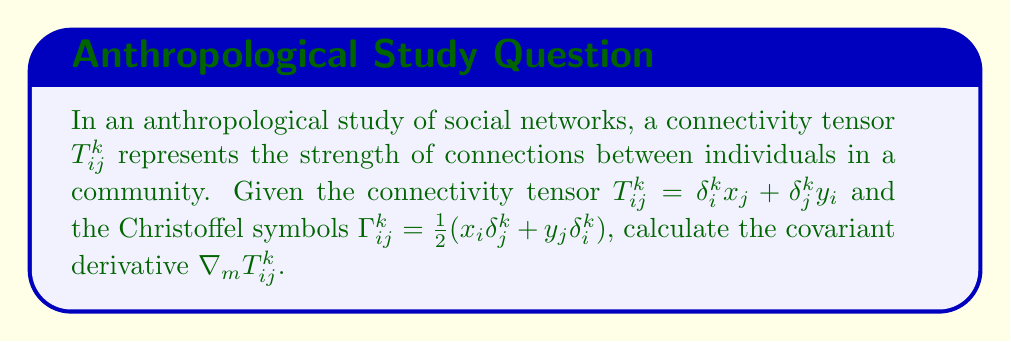Solve this math problem. To calculate the covariant derivative of the connectivity tensor, we follow these steps:

1) The covariant derivative of a (2,1) tensor is given by:

   $$\nabla_m T_{ij}^k = \partial_m T_{ij}^k + \Gamma_{ml}^k T_{ij}^l - \Gamma_{mi}^l T_{lj}^k - \Gamma_{mj}^l T_{il}^k$$

2) Let's calculate each term separately:

   a) $\partial_m T_{ij}^k = \partial_m (\delta_i^k x_j + \delta_j^k y_i) = \delta_i^k \delta_{jm} + \delta_j^k \delta_{im}$

   b) $\Gamma_{ml}^k T_{ij}^l = \frac{1}{2}(x_m \delta_l^k + y_l \delta_m^k)(\delta_i^l x_j + \delta_j^l y_i)$
      $= \frac{1}{2}(x_m \delta_i^k x_j + x_m \delta_j^k y_i + y_i \delta_m^k x_j + y_j \delta_m^k y_i)$

   c) $\Gamma_{mi}^l T_{lj}^k = \frac{1}{2}(x_m \delta_i^l + y_i \delta_m^l)(\delta_l^k x_j + \delta_j^k y_l)$
      $= \frac{1}{2}(x_m \delta_i^k x_j + x_m \delta_j^k y_i + y_i \delta_m^k x_j + y_i \delta_j^k y_m)$

   d) $\Gamma_{mj}^l T_{il}^k = \frac{1}{2}(x_m \delta_j^l + y_j \delta_m^l)(\delta_i^k x_l + \delta_l^k y_i)$
      $= \frac{1}{2}(x_m \delta_i^k x_j + x_m \delta_j^k y_i + y_j \delta_i^k x_m + y_j \delta_m^k y_i)$

3) Substituting these terms back into the covariant derivative formula:

   $$\nabla_m T_{ij}^k = (\delta_i^k \delta_{jm} + \delta_j^k \delta_{im}) + \frac{1}{2}(x_m \delta_i^k x_j + x_m \delta_j^k y_i + y_i \delta_m^k x_j + y_j \delta_m^k y_i) - \frac{1}{2}(x_m \delta_i^k x_j + x_m \delta_j^k y_i + y_i \delta_m^k x_j + y_i \delta_j^k y_m) - \frac{1}{2}(x_m \delta_i^k x_j + x_m \delta_j^k y_i + y_j \delta_i^k x_m + y_j \delta_m^k y_i)$$

4) Simplifying and cancelling out terms:

   $$\nabla_m T_{ij}^k = \delta_i^k \delta_{jm} + \delta_j^k \delta_{im} - \frac{1}{2}(y_i \delta_j^k y_m + y_j \delta_i^k x_m)$$

This is the final expression for the covariant derivative of the connectivity tensor.
Answer: $\nabla_m T_{ij}^k = \delta_i^k \delta_{jm} + \delta_j^k \delta_{im} - \frac{1}{2}(y_i \delta_j^k y_m + y_j \delta_i^k x_m)$ 